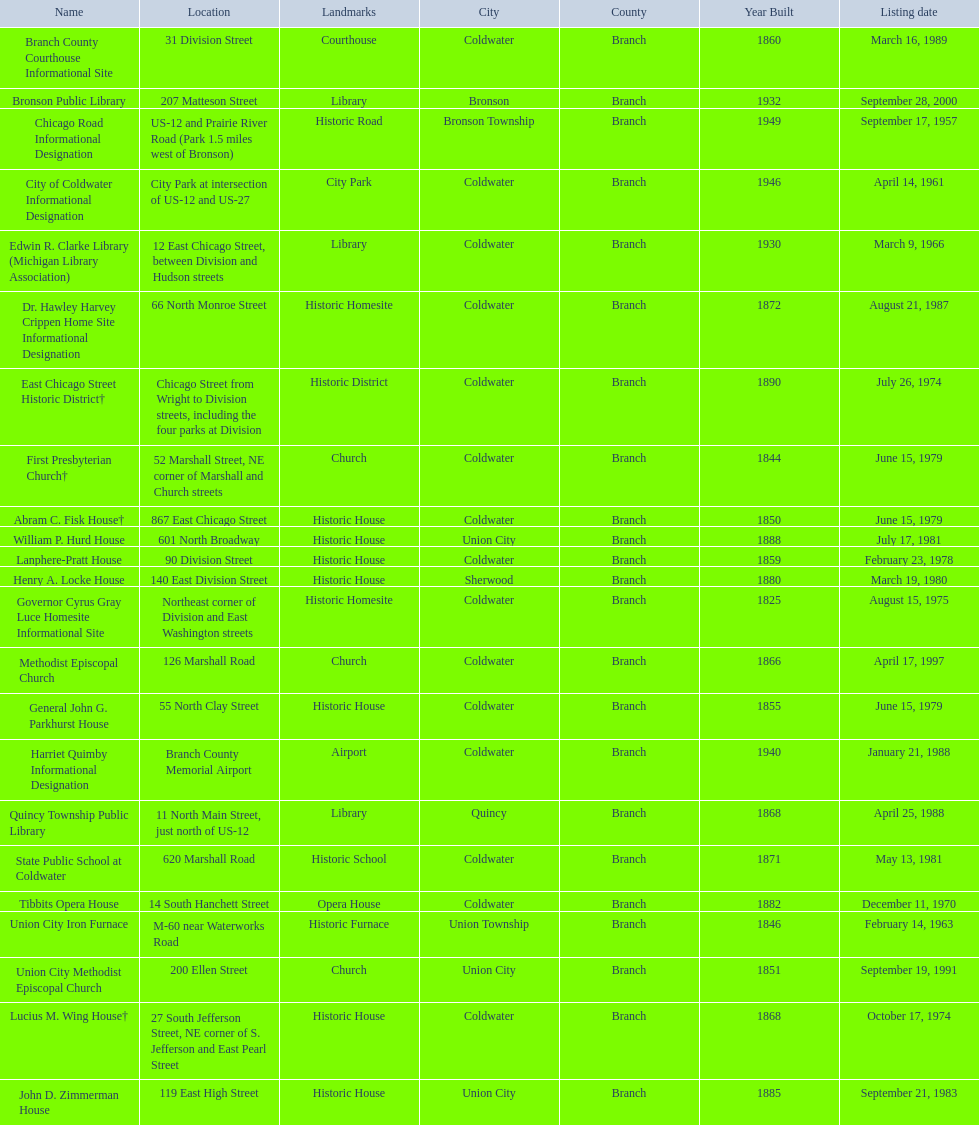Which site was listed earlier, the state public school or the edwin r. clarke library? Edwin R. Clarke Library. 